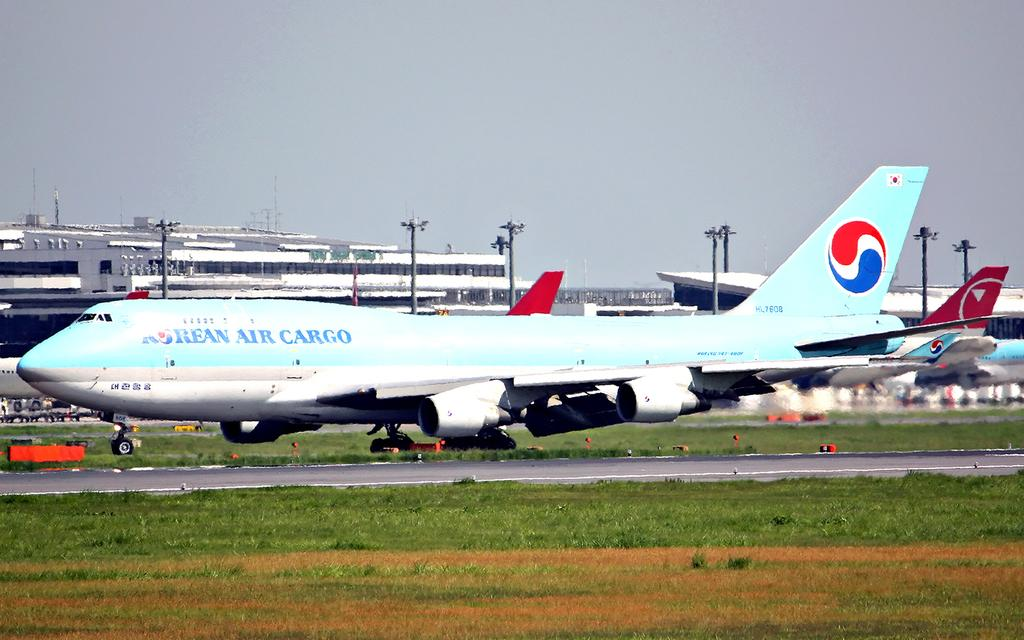<image>
Offer a succinct explanation of the picture presented. A blue and white Korean Air Cargo plane is parked on the grass. 